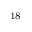Convert formula to latex. <formula><loc_0><loc_0><loc_500><loc_500>^ { 1 } 8</formula> 